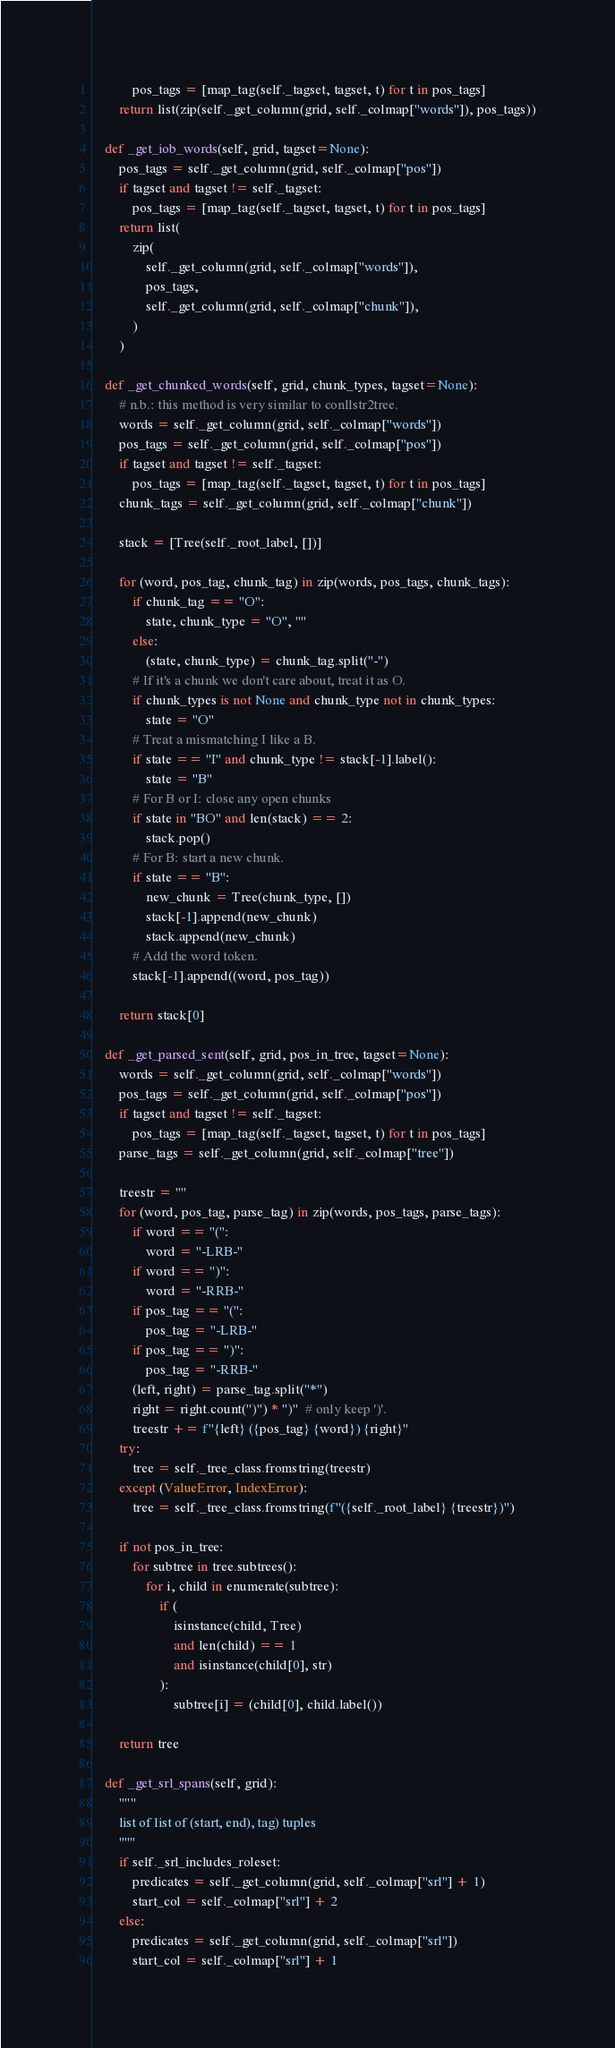<code> <loc_0><loc_0><loc_500><loc_500><_Python_>            pos_tags = [map_tag(self._tagset, tagset, t) for t in pos_tags]
        return list(zip(self._get_column(grid, self._colmap["words"]), pos_tags))

    def _get_iob_words(self, grid, tagset=None):
        pos_tags = self._get_column(grid, self._colmap["pos"])
        if tagset and tagset != self._tagset:
            pos_tags = [map_tag(self._tagset, tagset, t) for t in pos_tags]
        return list(
            zip(
                self._get_column(grid, self._colmap["words"]),
                pos_tags,
                self._get_column(grid, self._colmap["chunk"]),
            )
        )

    def _get_chunked_words(self, grid, chunk_types, tagset=None):
        # n.b.: this method is very similar to conllstr2tree.
        words = self._get_column(grid, self._colmap["words"])
        pos_tags = self._get_column(grid, self._colmap["pos"])
        if tagset and tagset != self._tagset:
            pos_tags = [map_tag(self._tagset, tagset, t) for t in pos_tags]
        chunk_tags = self._get_column(grid, self._colmap["chunk"])

        stack = [Tree(self._root_label, [])]

        for (word, pos_tag, chunk_tag) in zip(words, pos_tags, chunk_tags):
            if chunk_tag == "O":
                state, chunk_type = "O", ""
            else:
                (state, chunk_type) = chunk_tag.split("-")
            # If it's a chunk we don't care about, treat it as O.
            if chunk_types is not None and chunk_type not in chunk_types:
                state = "O"
            # Treat a mismatching I like a B.
            if state == "I" and chunk_type != stack[-1].label():
                state = "B"
            # For B or I: close any open chunks
            if state in "BO" and len(stack) == 2:
                stack.pop()
            # For B: start a new chunk.
            if state == "B":
                new_chunk = Tree(chunk_type, [])
                stack[-1].append(new_chunk)
                stack.append(new_chunk)
            # Add the word token.
            stack[-1].append((word, pos_tag))

        return stack[0]

    def _get_parsed_sent(self, grid, pos_in_tree, tagset=None):
        words = self._get_column(grid, self._colmap["words"])
        pos_tags = self._get_column(grid, self._colmap["pos"])
        if tagset and tagset != self._tagset:
            pos_tags = [map_tag(self._tagset, tagset, t) for t in pos_tags]
        parse_tags = self._get_column(grid, self._colmap["tree"])

        treestr = ""
        for (word, pos_tag, parse_tag) in zip(words, pos_tags, parse_tags):
            if word == "(":
                word = "-LRB-"
            if word == ")":
                word = "-RRB-"
            if pos_tag == "(":
                pos_tag = "-LRB-"
            if pos_tag == ")":
                pos_tag = "-RRB-"
            (left, right) = parse_tag.split("*")
            right = right.count(")") * ")"  # only keep ')'.
            treestr += f"{left} ({pos_tag} {word}) {right}"
        try:
            tree = self._tree_class.fromstring(treestr)
        except (ValueError, IndexError):
            tree = self._tree_class.fromstring(f"({self._root_label} {treestr})")

        if not pos_in_tree:
            for subtree in tree.subtrees():
                for i, child in enumerate(subtree):
                    if (
                        isinstance(child, Tree)
                        and len(child) == 1
                        and isinstance(child[0], str)
                    ):
                        subtree[i] = (child[0], child.label())

        return tree

    def _get_srl_spans(self, grid):
        """
        list of list of (start, end), tag) tuples
        """
        if self._srl_includes_roleset:
            predicates = self._get_column(grid, self._colmap["srl"] + 1)
            start_col = self._colmap["srl"] + 2
        else:
            predicates = self._get_column(grid, self._colmap["srl"])
            start_col = self._colmap["srl"] + 1
</code> 